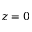<formula> <loc_0><loc_0><loc_500><loc_500>z = 0</formula> 